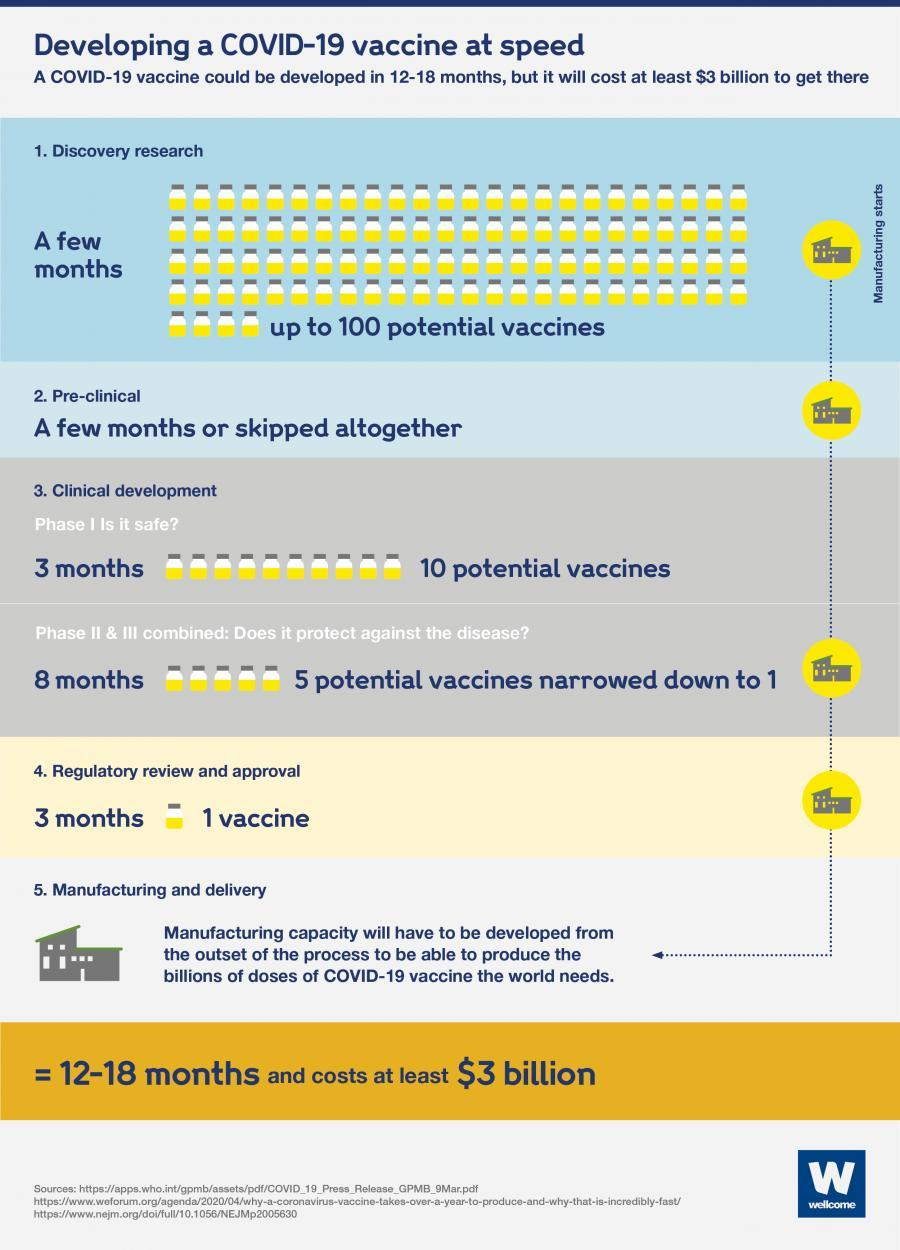How many steps lead to a vaccine to be available?
Answer the question with a short phrase. 5 How many vaccines will be developed during Phase I? 10 